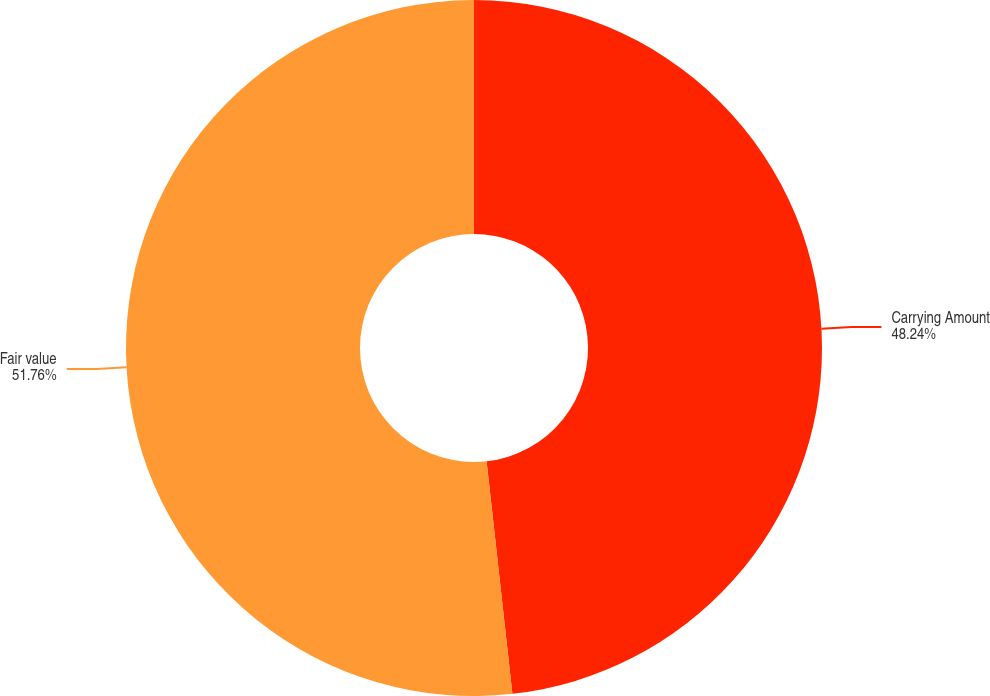Convert chart. <chart><loc_0><loc_0><loc_500><loc_500><pie_chart><fcel>Carrying Amount<fcel>Fair value<nl><fcel>48.24%<fcel>51.76%<nl></chart> 